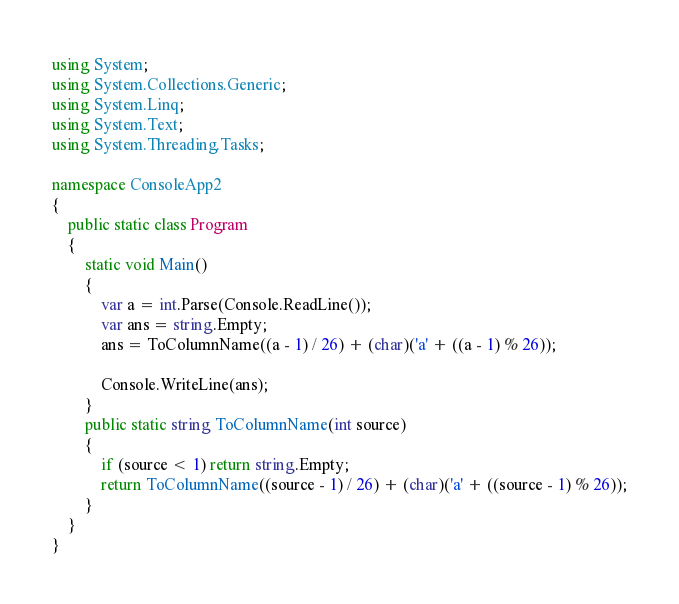Convert code to text. <code><loc_0><loc_0><loc_500><loc_500><_C#_>using System;
using System.Collections.Generic;
using System.Linq;
using System.Text;
using System.Threading.Tasks;
 
namespace ConsoleApp2
{
    public static class Program
    {
        static void Main()
        {
            var a = int.Parse(Console.ReadLine());
            var ans = string.Empty;
            ans = ToColumnName((a - 1) / 26) + (char)('a' + ((a - 1) % 26));
 
            Console.WriteLine(ans);
        }
        public static string ToColumnName(int source)
        {
            if (source < 1) return string.Empty;
            return ToColumnName((source - 1) / 26) + (char)('a' + ((source - 1) % 26));
        }
    }
}</code> 